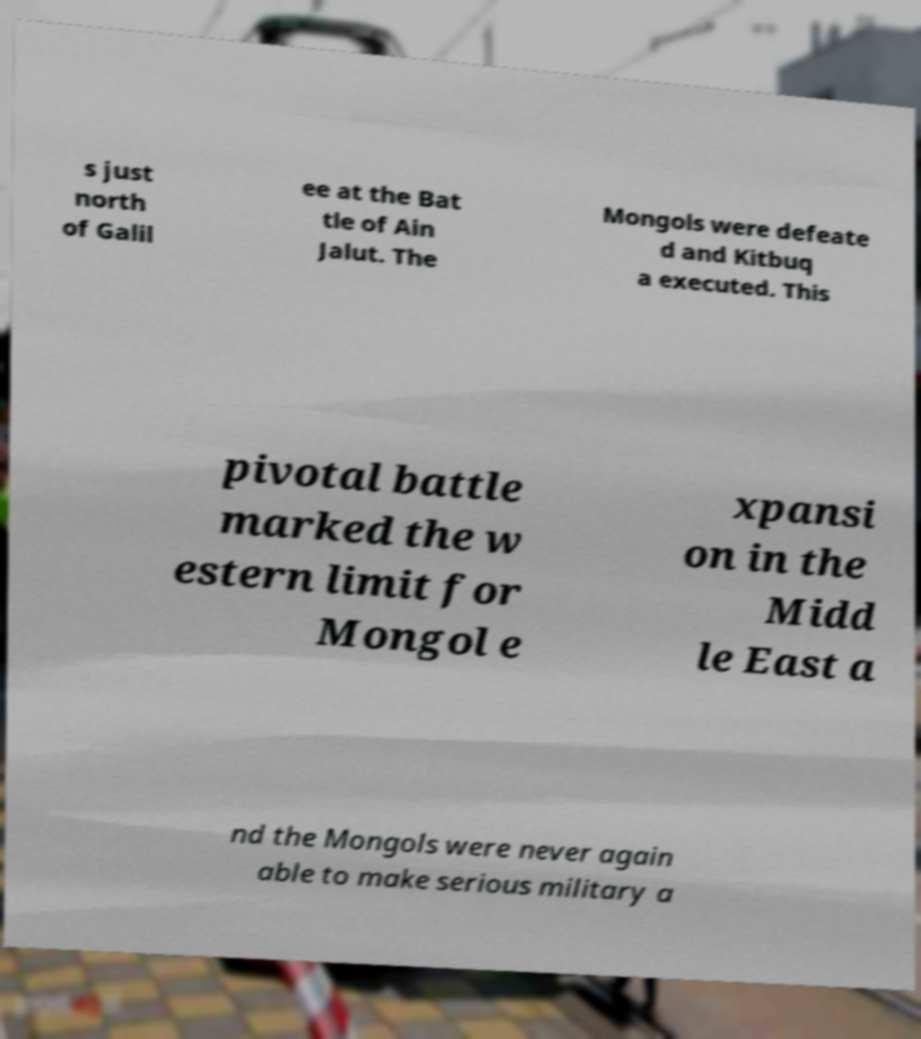Could you assist in decoding the text presented in this image and type it out clearly? s just north of Galil ee at the Bat tle of Ain Jalut. The Mongols were defeate d and Kitbuq a executed. This pivotal battle marked the w estern limit for Mongol e xpansi on in the Midd le East a nd the Mongols were never again able to make serious military a 